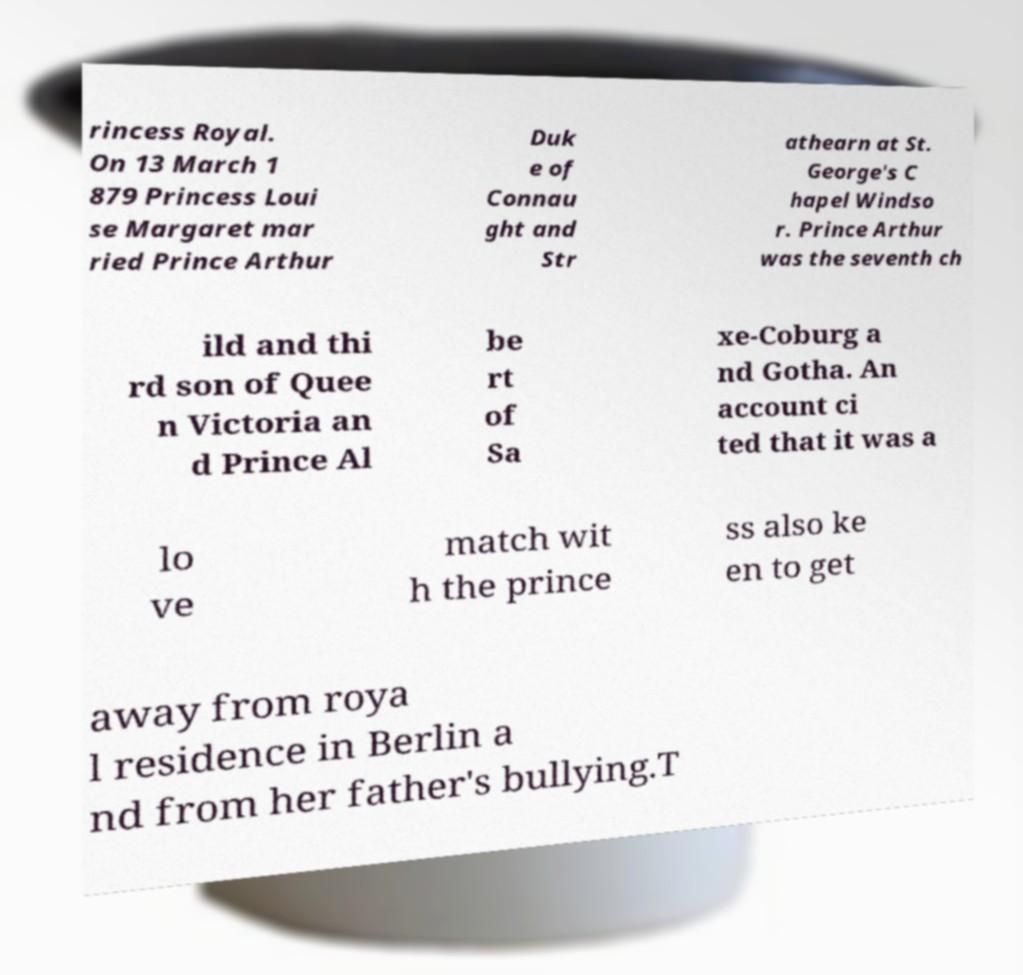Please identify and transcribe the text found in this image. rincess Royal. On 13 March 1 879 Princess Loui se Margaret mar ried Prince Arthur Duk e of Connau ght and Str athearn at St. George's C hapel Windso r. Prince Arthur was the seventh ch ild and thi rd son of Quee n Victoria an d Prince Al be rt of Sa xe-Coburg a nd Gotha. An account ci ted that it was a lo ve match wit h the prince ss also ke en to get away from roya l residence in Berlin a nd from her father's bullying.T 